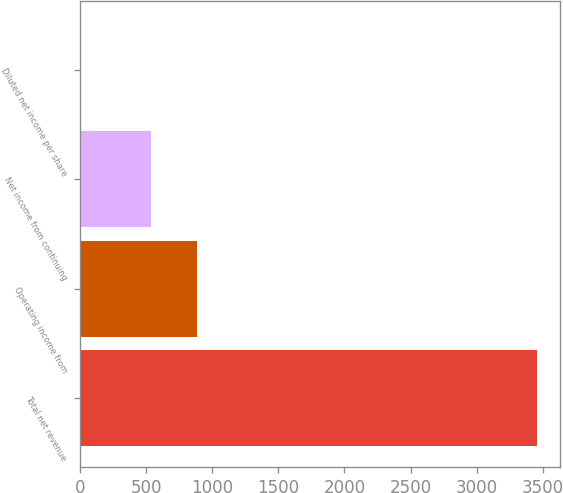Convert chart to OTSL. <chart><loc_0><loc_0><loc_500><loc_500><bar_chart><fcel>Total net revenue<fcel>Operating income from<fcel>Net income from continuing<fcel>Diluted net income per share<nl><fcel>3455<fcel>884.33<fcel>539<fcel>1.66<nl></chart> 